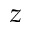Convert formula to latex. <formula><loc_0><loc_0><loc_500><loc_500>z</formula> 